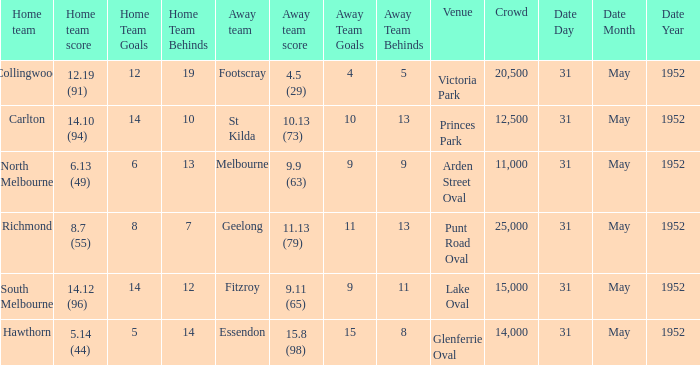Who was the away team at the game at Victoria Park? Footscray. 